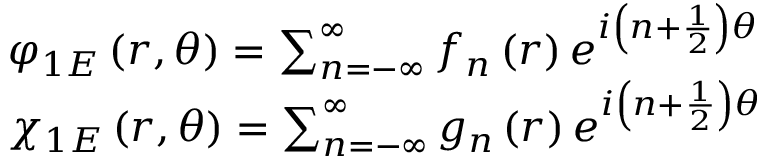Convert formula to latex. <formula><loc_0><loc_0><loc_500><loc_500>\begin{array} { l } { { \varphi _ { 1 E } \left ( r , \theta \right ) = \sum _ { n = - \infty } ^ { \infty } f _ { n } \left ( r \right ) e ^ { i \left ( n + \frac { 1 } { 2 } \right ) \theta } } } \\ { { \chi _ { 1 E } \left ( r , \theta \right ) = \sum _ { n = - \infty } ^ { \infty } g _ { n } \left ( r \right ) e ^ { i \left ( n + \frac { 1 } { 2 } \right ) \theta } } } \end{array}</formula> 